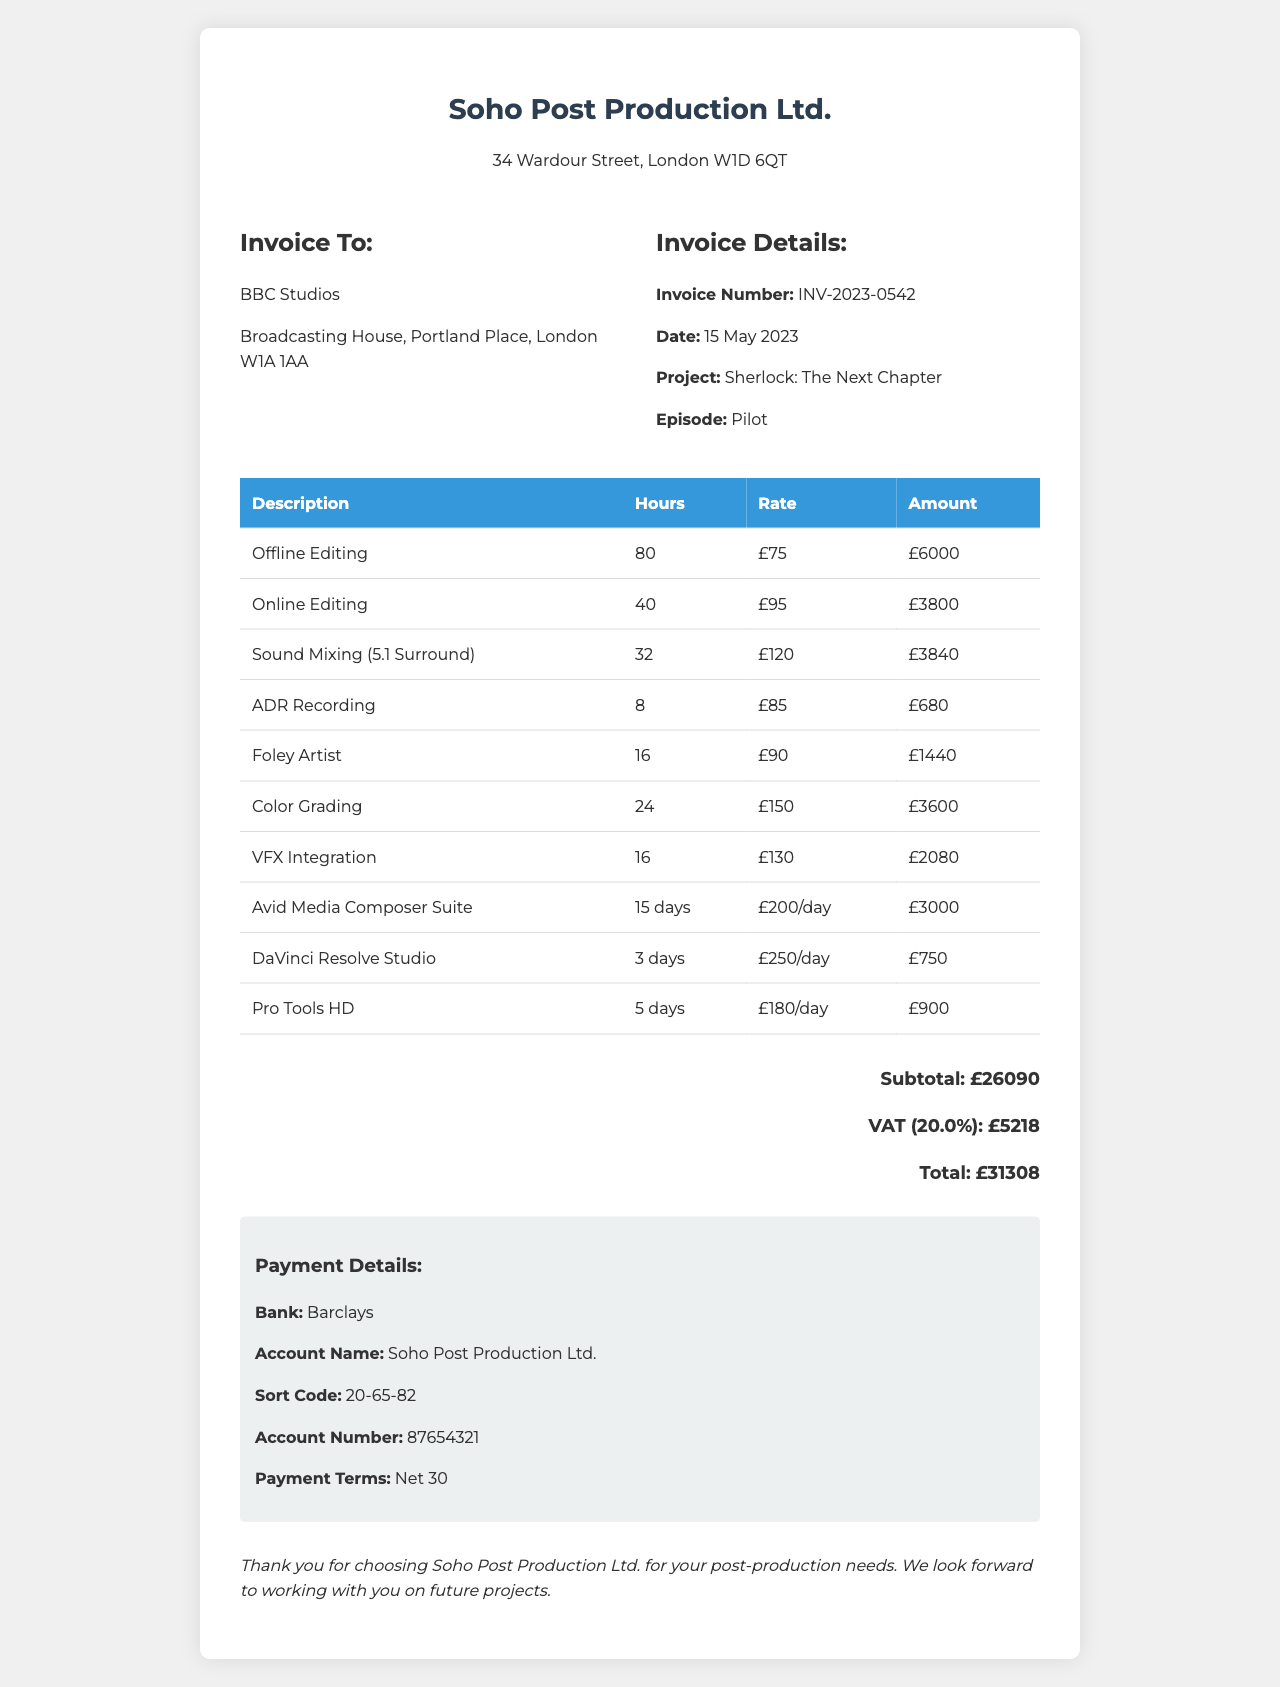what is the company name? The company name is listed prominently at the top of the invoice.
Answer: Soho Post Production Ltd what is the invoice number? The invoice number is a unique identifier for the transaction, found in the invoice details section.
Answer: INV-2023-0542 how many hours were spent on Offline Editing? The number of hours for each service is provided in the table of services.
Answer: 80 what is the total amount due? The total amount is the final figure listed at the bottom of the invoice, including subtotal and VAT.
Answer: £31,308 how many days was the Avid Media Composer Suite used? The number of days for each piece of equipment is listed in the equipment section of the invoice.
Answer: 15 days what is the VAT rate applied? The VAT rate is displayed in the financial details of the document.
Answer: 20% who is the client name? The client name is mentioned in the invoice, identifying the recipient of the services.
Answer: BBC Studios what payment terms are specified? The payment terms outline the due date for payment and are stated in the invoice details.
Answer: Net 30 how many workshops were held for Sound Mixing? The hours allocated for each service are noted in the services section.
Answer: 32 